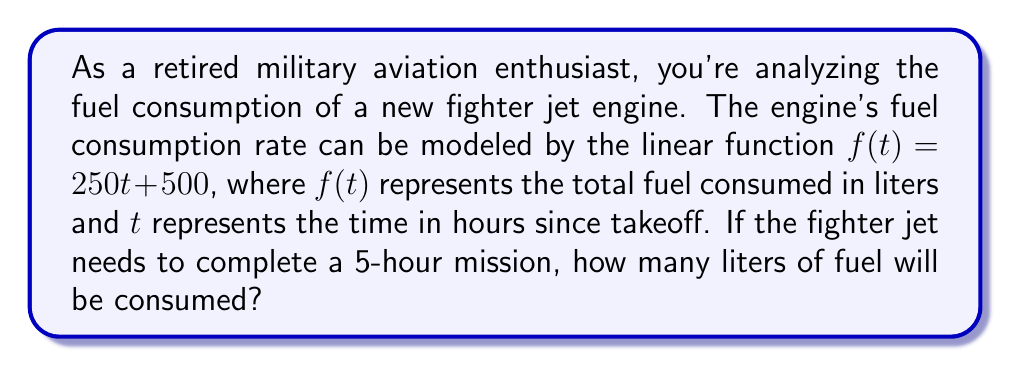Can you solve this math problem? To solve this problem, we need to use the given linear function and evaluate it at $t = 5$ hours. Let's break it down step-by-step:

1) The linear function modeling fuel consumption is:
   $$f(t) = 250t + 500$$

2) We need to find $f(5)$, which represents the fuel consumed after 5 hours:
   $$f(5) = 250(5) + 500$$

3) Let's calculate:
   $$f(5) = 1250 + 500$$
   $$f(5) = 1750$$

4) Interpret the result:
   The function $f(t)$ gives us the total fuel consumed in liters. Therefore, after 5 hours, the fighter jet will have consumed 1750 liters of fuel.

Note: The slope of 250 in the function $f(t) = 250t + 500$ represents the rate of fuel consumption per hour (250 liters/hour). The y-intercept of 500 could represent an initial amount of fuel used during takeoff procedures.
Answer: The fighter jet will consume 1750 liters of fuel during the 5-hour mission. 